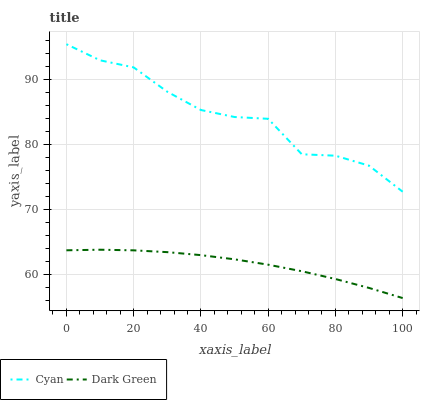Does Dark Green have the minimum area under the curve?
Answer yes or no. Yes. Does Cyan have the maximum area under the curve?
Answer yes or no. Yes. Does Dark Green have the maximum area under the curve?
Answer yes or no. No. Is Dark Green the smoothest?
Answer yes or no. Yes. Is Cyan the roughest?
Answer yes or no. Yes. Is Dark Green the roughest?
Answer yes or no. No. Does Dark Green have the lowest value?
Answer yes or no. Yes. Does Cyan have the highest value?
Answer yes or no. Yes. Does Dark Green have the highest value?
Answer yes or no. No. Is Dark Green less than Cyan?
Answer yes or no. Yes. Is Cyan greater than Dark Green?
Answer yes or no. Yes. Does Dark Green intersect Cyan?
Answer yes or no. No. 